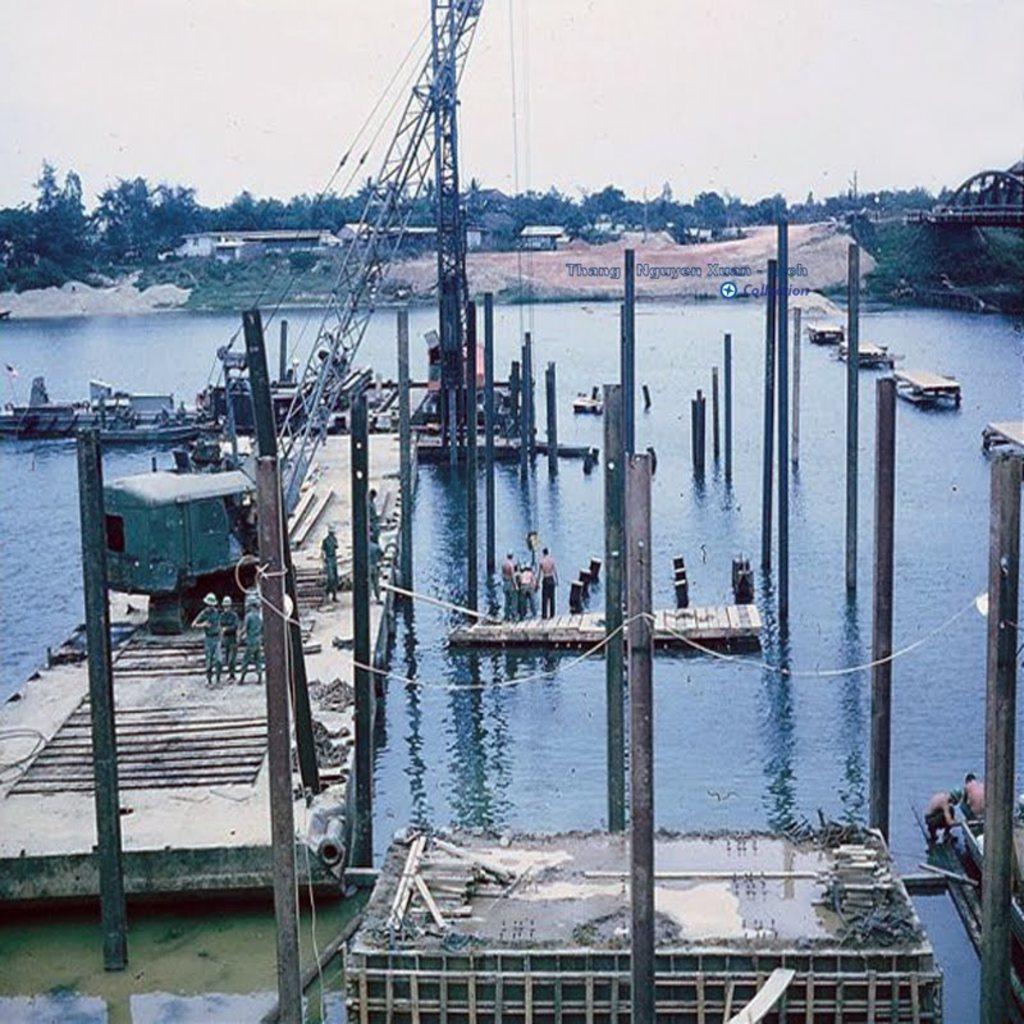How would you summarize this image in a sentence or two? The picture is clicked in a river where we observe the construction equipment is on the bench and there are pillars building in the river. 